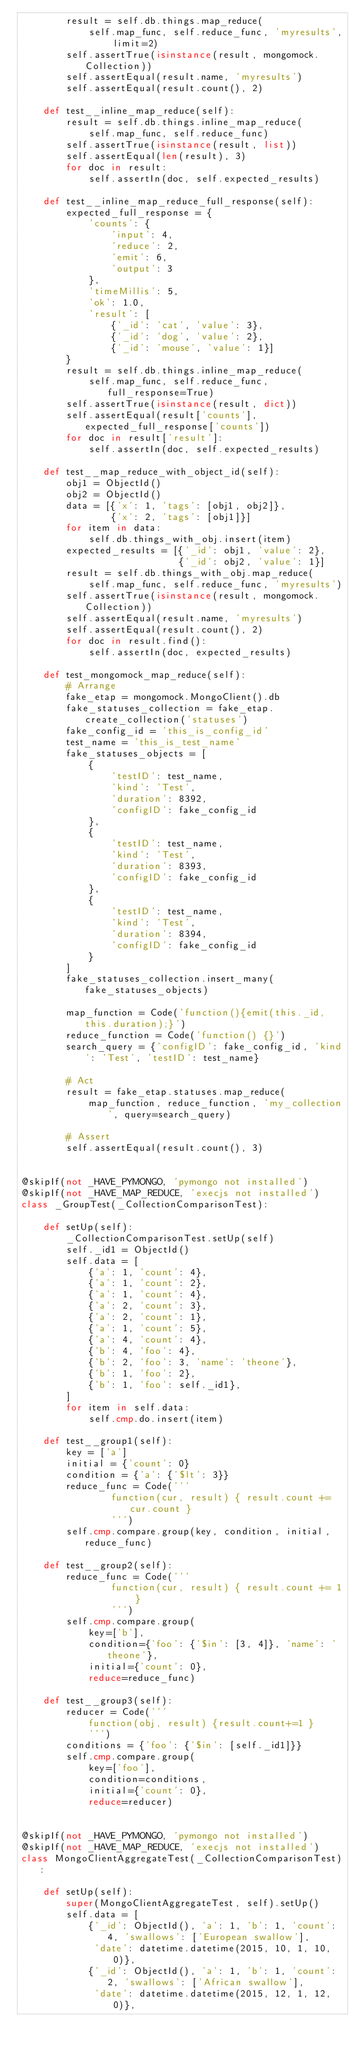Convert code to text. <code><loc_0><loc_0><loc_500><loc_500><_Python_>        result = self.db.things.map_reduce(
            self.map_func, self.reduce_func, 'myresults', limit=2)
        self.assertTrue(isinstance(result, mongomock.Collection))
        self.assertEqual(result.name, 'myresults')
        self.assertEqual(result.count(), 2)

    def test__inline_map_reduce(self):
        result = self.db.things.inline_map_reduce(
            self.map_func, self.reduce_func)
        self.assertTrue(isinstance(result, list))
        self.assertEqual(len(result), 3)
        for doc in result:
            self.assertIn(doc, self.expected_results)

    def test__inline_map_reduce_full_response(self):
        expected_full_response = {
            'counts': {
                'input': 4,
                'reduce': 2,
                'emit': 6,
                'output': 3
            },
            'timeMillis': 5,
            'ok': 1.0,
            'result': [
                {'_id': 'cat', 'value': 3},
                {'_id': 'dog', 'value': 2},
                {'_id': 'mouse', 'value': 1}]
        }
        result = self.db.things.inline_map_reduce(
            self.map_func, self.reduce_func, full_response=True)
        self.assertTrue(isinstance(result, dict))
        self.assertEqual(result['counts'], expected_full_response['counts'])
        for doc in result['result']:
            self.assertIn(doc, self.expected_results)

    def test__map_reduce_with_object_id(self):
        obj1 = ObjectId()
        obj2 = ObjectId()
        data = [{'x': 1, 'tags': [obj1, obj2]},
                {'x': 2, 'tags': [obj1]}]
        for item in data:
            self.db.things_with_obj.insert(item)
        expected_results = [{'_id': obj1, 'value': 2},
                            {'_id': obj2, 'value': 1}]
        result = self.db.things_with_obj.map_reduce(
            self.map_func, self.reduce_func, 'myresults')
        self.assertTrue(isinstance(result, mongomock.Collection))
        self.assertEqual(result.name, 'myresults')
        self.assertEqual(result.count(), 2)
        for doc in result.find():
            self.assertIn(doc, expected_results)

    def test_mongomock_map_reduce(self):
        # Arrange
        fake_etap = mongomock.MongoClient().db
        fake_statuses_collection = fake_etap.create_collection('statuses')
        fake_config_id = 'this_is_config_id'
        test_name = 'this_is_test_name'
        fake_statuses_objects = [
            {
                'testID': test_name,
                'kind': 'Test',
                'duration': 8392,
                'configID': fake_config_id
            },
            {
                'testID': test_name,
                'kind': 'Test',
                'duration': 8393,
                'configID': fake_config_id
            },
            {
                'testID': test_name,
                'kind': 'Test',
                'duration': 8394,
                'configID': fake_config_id
            }
        ]
        fake_statuses_collection.insert_many(fake_statuses_objects)

        map_function = Code('function(){emit(this._id, this.duration);}')
        reduce_function = Code('function() {}')
        search_query = {'configID': fake_config_id, 'kind': 'Test', 'testID': test_name}

        # Act
        result = fake_etap.statuses.map_reduce(
            map_function, reduce_function, 'my_collection', query=search_query)

        # Assert
        self.assertEqual(result.count(), 3)


@skipIf(not _HAVE_PYMONGO, 'pymongo not installed')
@skipIf(not _HAVE_MAP_REDUCE, 'execjs not installed')
class _GroupTest(_CollectionComparisonTest):

    def setUp(self):
        _CollectionComparisonTest.setUp(self)
        self._id1 = ObjectId()
        self.data = [
            {'a': 1, 'count': 4},
            {'a': 1, 'count': 2},
            {'a': 1, 'count': 4},
            {'a': 2, 'count': 3},
            {'a': 2, 'count': 1},
            {'a': 1, 'count': 5},
            {'a': 4, 'count': 4},
            {'b': 4, 'foo': 4},
            {'b': 2, 'foo': 3, 'name': 'theone'},
            {'b': 1, 'foo': 2},
            {'b': 1, 'foo': self._id1},
        ]
        for item in self.data:
            self.cmp.do.insert(item)

    def test__group1(self):
        key = ['a']
        initial = {'count': 0}
        condition = {'a': {'$lt': 3}}
        reduce_func = Code('''
                function(cur, result) { result.count += cur.count }
                ''')
        self.cmp.compare.group(key, condition, initial, reduce_func)

    def test__group2(self):
        reduce_func = Code('''
                function(cur, result) { result.count += 1 }
                ''')
        self.cmp.compare.group(
            key=['b'],
            condition={'foo': {'$in': [3, 4]}, 'name': 'theone'},
            initial={'count': 0},
            reduce=reduce_func)

    def test__group3(self):
        reducer = Code('''
            function(obj, result) {result.count+=1 }
            ''')
        conditions = {'foo': {'$in': [self._id1]}}
        self.cmp.compare.group(
            key=['foo'],
            condition=conditions,
            initial={'count': 0},
            reduce=reducer)


@skipIf(not _HAVE_PYMONGO, 'pymongo not installed')
@skipIf(not _HAVE_MAP_REDUCE, 'execjs not installed')
class MongoClientAggregateTest(_CollectionComparisonTest):

    def setUp(self):
        super(MongoClientAggregateTest, self).setUp()
        self.data = [
            {'_id': ObjectId(), 'a': 1, 'b': 1, 'count': 4, 'swallows': ['European swallow'],
             'date': datetime.datetime(2015, 10, 1, 10, 0)},
            {'_id': ObjectId(), 'a': 1, 'b': 1, 'count': 2, 'swallows': ['African swallow'],
             'date': datetime.datetime(2015, 12, 1, 12, 0)},</code> 